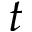<formula> <loc_0><loc_0><loc_500><loc_500>t</formula> 